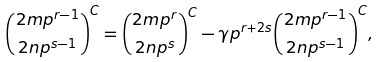Convert formula to latex. <formula><loc_0><loc_0><loc_500><loc_500>\binom { 2 m p ^ { r - 1 } } { 2 n p ^ { s - 1 } } ^ { C } = \binom { 2 m p ^ { r } } { 2 n p ^ { s } } ^ { C } - \gamma p ^ { r + 2 s } \binom { 2 m p ^ { r - 1 } } { 2 n p ^ { s - 1 } } ^ { C } ,</formula> 